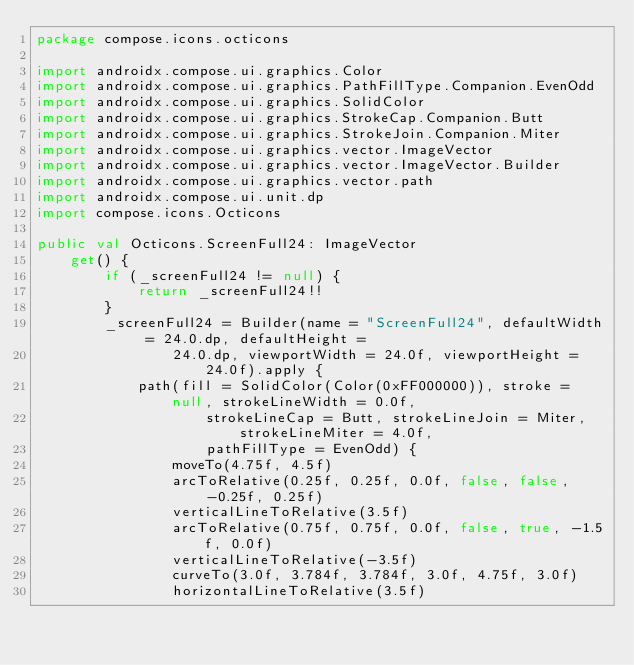<code> <loc_0><loc_0><loc_500><loc_500><_Kotlin_>package compose.icons.octicons

import androidx.compose.ui.graphics.Color
import androidx.compose.ui.graphics.PathFillType.Companion.EvenOdd
import androidx.compose.ui.graphics.SolidColor
import androidx.compose.ui.graphics.StrokeCap.Companion.Butt
import androidx.compose.ui.graphics.StrokeJoin.Companion.Miter
import androidx.compose.ui.graphics.vector.ImageVector
import androidx.compose.ui.graphics.vector.ImageVector.Builder
import androidx.compose.ui.graphics.vector.path
import androidx.compose.ui.unit.dp
import compose.icons.Octicons

public val Octicons.ScreenFull24: ImageVector
    get() {
        if (_screenFull24 != null) {
            return _screenFull24!!
        }
        _screenFull24 = Builder(name = "ScreenFull24", defaultWidth = 24.0.dp, defaultHeight =
                24.0.dp, viewportWidth = 24.0f, viewportHeight = 24.0f).apply {
            path(fill = SolidColor(Color(0xFF000000)), stroke = null, strokeLineWidth = 0.0f,
                    strokeLineCap = Butt, strokeLineJoin = Miter, strokeLineMiter = 4.0f,
                    pathFillType = EvenOdd) {
                moveTo(4.75f, 4.5f)
                arcToRelative(0.25f, 0.25f, 0.0f, false, false, -0.25f, 0.25f)
                verticalLineToRelative(3.5f)
                arcToRelative(0.75f, 0.75f, 0.0f, false, true, -1.5f, 0.0f)
                verticalLineToRelative(-3.5f)
                curveTo(3.0f, 3.784f, 3.784f, 3.0f, 4.75f, 3.0f)
                horizontalLineToRelative(3.5f)</code> 